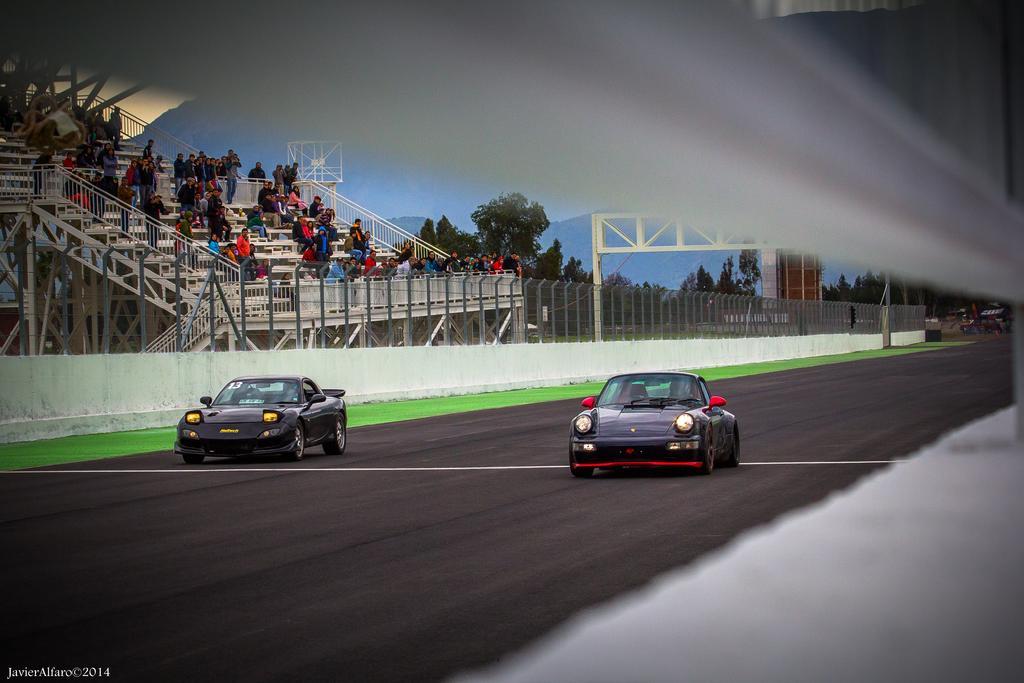In one or two sentences, can you explain what this image depicts? In this picture we can see vehicles on the road and in the background we can see people,trees,mountains. 